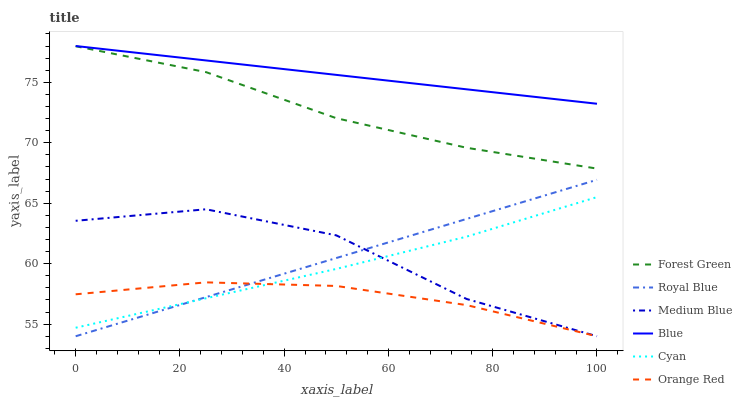Does Orange Red have the minimum area under the curve?
Answer yes or no. Yes. Does Blue have the maximum area under the curve?
Answer yes or no. Yes. Does Medium Blue have the minimum area under the curve?
Answer yes or no. No. Does Medium Blue have the maximum area under the curve?
Answer yes or no. No. Is Royal Blue the smoothest?
Answer yes or no. Yes. Is Medium Blue the roughest?
Answer yes or no. Yes. Is Medium Blue the smoothest?
Answer yes or no. No. Is Royal Blue the roughest?
Answer yes or no. No. Does Medium Blue have the lowest value?
Answer yes or no. Yes. Does Forest Green have the lowest value?
Answer yes or no. No. Does Blue have the highest value?
Answer yes or no. Yes. Does Medium Blue have the highest value?
Answer yes or no. No. Is Forest Green less than Blue?
Answer yes or no. Yes. Is Forest Green greater than Orange Red?
Answer yes or no. Yes. Does Cyan intersect Royal Blue?
Answer yes or no. Yes. Is Cyan less than Royal Blue?
Answer yes or no. No. Is Cyan greater than Royal Blue?
Answer yes or no. No. Does Forest Green intersect Blue?
Answer yes or no. No. 